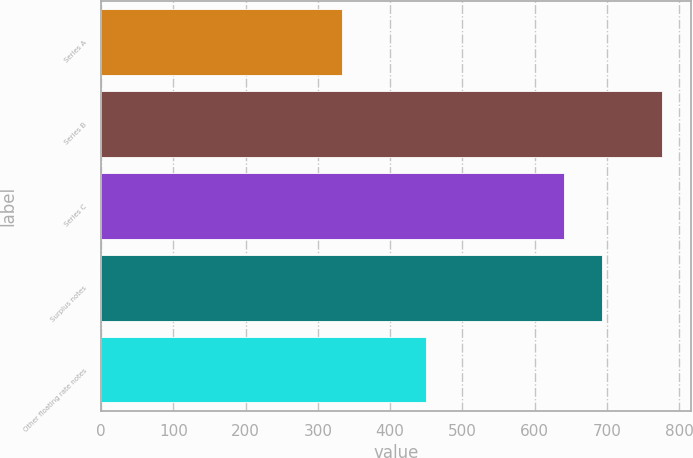Convert chart to OTSL. <chart><loc_0><loc_0><loc_500><loc_500><bar_chart><fcel>Series A<fcel>Series B<fcel>Series C<fcel>Surplus notes<fcel>Other floating rate notes<nl><fcel>333<fcel>777<fcel>640<fcel>693<fcel>450<nl></chart> 